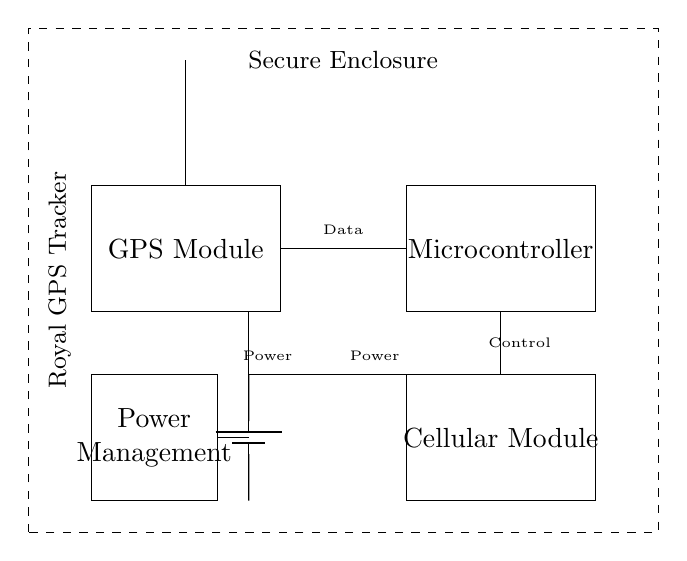What components are present in the circuit? The components visible in the circuit diagram are the GPS module, microcontroller, battery, antenna, cellular module, and power management system. These are identified as separate rectangles and elements within the circuit.
Answer: GPS module, microcontroller, battery, antenna, cellular module, power management What does the power management system do? The power management system regulates the power supply to various components, ensuring that the GPS module, microcontroller, and cellular module operate within their required voltage levels. This is essential to prevent damage and ensure efficient operation.
Answer: Regulates power supply How many modules are there? There are four primary modules in the circuit: the GPS module, microcontroller, cellular module, and power management module. Each module is distinctly represented in the diagram.
Answer: Four What is the connection type between the GPS module and the microcontroller? The connection between the GPS module and the microcontroller is a direct line, representing data transfer. This indicates that the GPS module sends its positional data directly to the microcontroller for processing.
Answer: Direct connection Which component is responsible for transmitting location data? The cellular module is responsible for transmitting location data from the microcontroller to an external network, allowing for tracking and monitoring. It connects directly to the microcontroller, facilitating communication.
Answer: Cellular module What is the role of the antenna in this circuit? The antenna is crucial for receiving GPS signals and transmitting data from the cellular module. It enhances the circuit's ability to connect with satellites for accurate positioning and with networks for data transmission.
Answer: Receives signals and transmits data What is the significance of the secure enclosure? The secure enclosure is important for protecting all components of the circuit from physical damage, tampering, or unauthorized access. This ensures the integrity and functionality of the GPS tracking system.
Answer: Protects components 